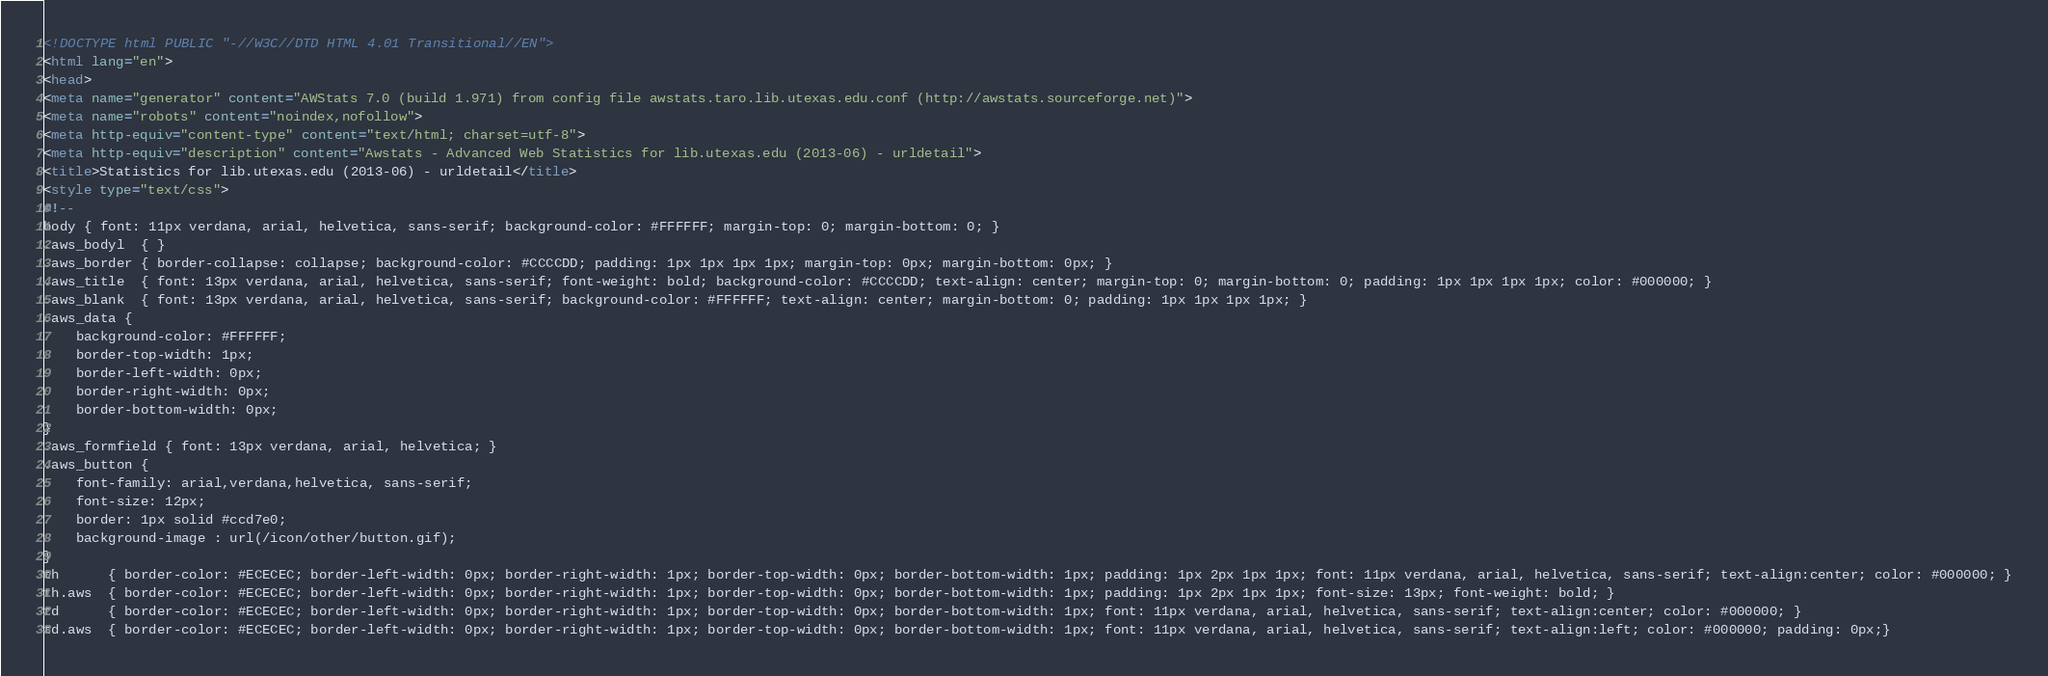<code> <loc_0><loc_0><loc_500><loc_500><_HTML_><!DOCTYPE html PUBLIC "-//W3C//DTD HTML 4.01 Transitional//EN">
<html lang="en">
<head>
<meta name="generator" content="AWStats 7.0 (build 1.971) from config file awstats.taro.lib.utexas.edu.conf (http://awstats.sourceforge.net)">
<meta name="robots" content="noindex,nofollow">
<meta http-equiv="content-type" content="text/html; charset=utf-8">
<meta http-equiv="description" content="Awstats - Advanced Web Statistics for lib.utexas.edu (2013-06) - urldetail">
<title>Statistics for lib.utexas.edu (2013-06) - urldetail</title>
<style type="text/css">
<!--
body { font: 11px verdana, arial, helvetica, sans-serif; background-color: #FFFFFF; margin-top: 0; margin-bottom: 0; }
.aws_bodyl  { }
.aws_border { border-collapse: collapse; background-color: #CCCCDD; padding: 1px 1px 1px 1px; margin-top: 0px; margin-bottom: 0px; }
.aws_title  { font: 13px verdana, arial, helvetica, sans-serif; font-weight: bold; background-color: #CCCCDD; text-align: center; margin-top: 0; margin-bottom: 0; padding: 1px 1px 1px 1px; color: #000000; }
.aws_blank  { font: 13px verdana, arial, helvetica, sans-serif; background-color: #FFFFFF; text-align: center; margin-bottom: 0; padding: 1px 1px 1px 1px; }
.aws_data {
	background-color: #FFFFFF;
	border-top-width: 1px;   
	border-left-width: 0px;  
	border-right-width: 0px; 
	border-bottom-width: 0px;
}
.aws_formfield { font: 13px verdana, arial, helvetica; }
.aws_button {
	font-family: arial,verdana,helvetica, sans-serif;
	font-size: 12px;
	border: 1px solid #ccd7e0;
	background-image : url(/icon/other/button.gif);
}
th		{ border-color: #ECECEC; border-left-width: 0px; border-right-width: 1px; border-top-width: 0px; border-bottom-width: 1px; padding: 1px 2px 1px 1px; font: 11px verdana, arial, helvetica, sans-serif; text-align:center; color: #000000; }
th.aws	{ border-color: #ECECEC; border-left-width: 0px; border-right-width: 1px; border-top-width: 0px; border-bottom-width: 1px; padding: 1px 2px 1px 1px; font-size: 13px; font-weight: bold; }
td		{ border-color: #ECECEC; border-left-width: 0px; border-right-width: 1px; border-top-width: 0px; border-bottom-width: 1px; font: 11px verdana, arial, helvetica, sans-serif; text-align:center; color: #000000; }
td.aws	{ border-color: #ECECEC; border-left-width: 0px; border-right-width: 1px; border-top-width: 0px; border-bottom-width: 1px; font: 11px verdana, arial, helvetica, sans-serif; text-align:left; color: #000000; padding: 0px;}</code> 